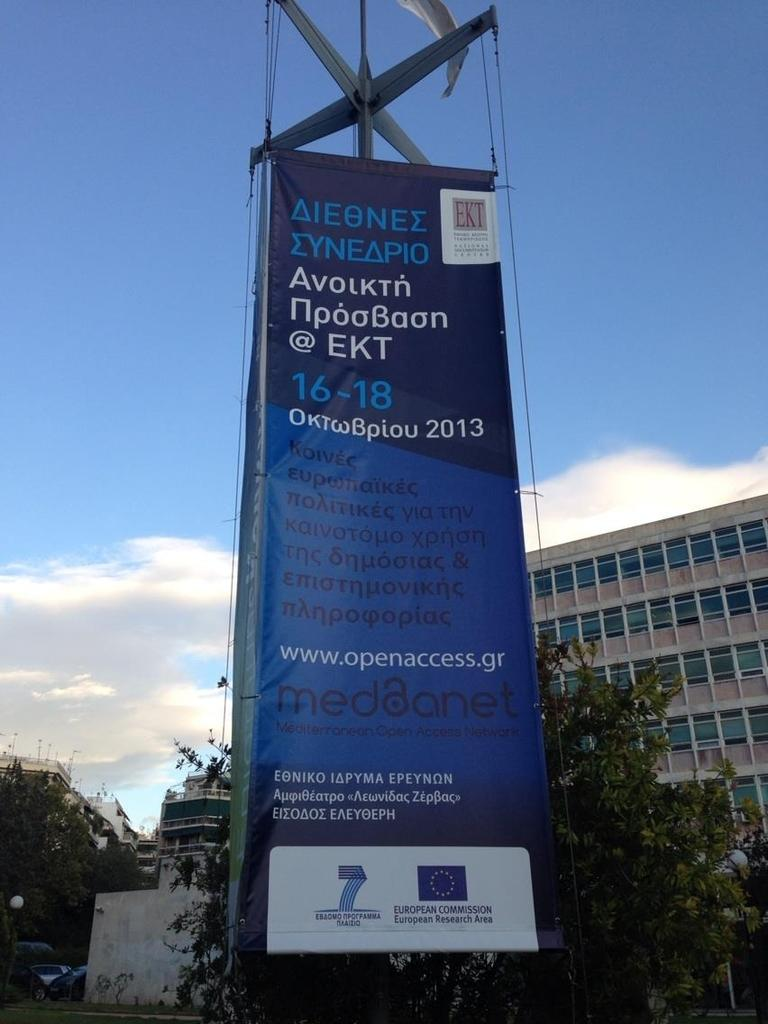Provide a one-sentence caption for the provided image. A russian sign with EKT in the upper right corner. 